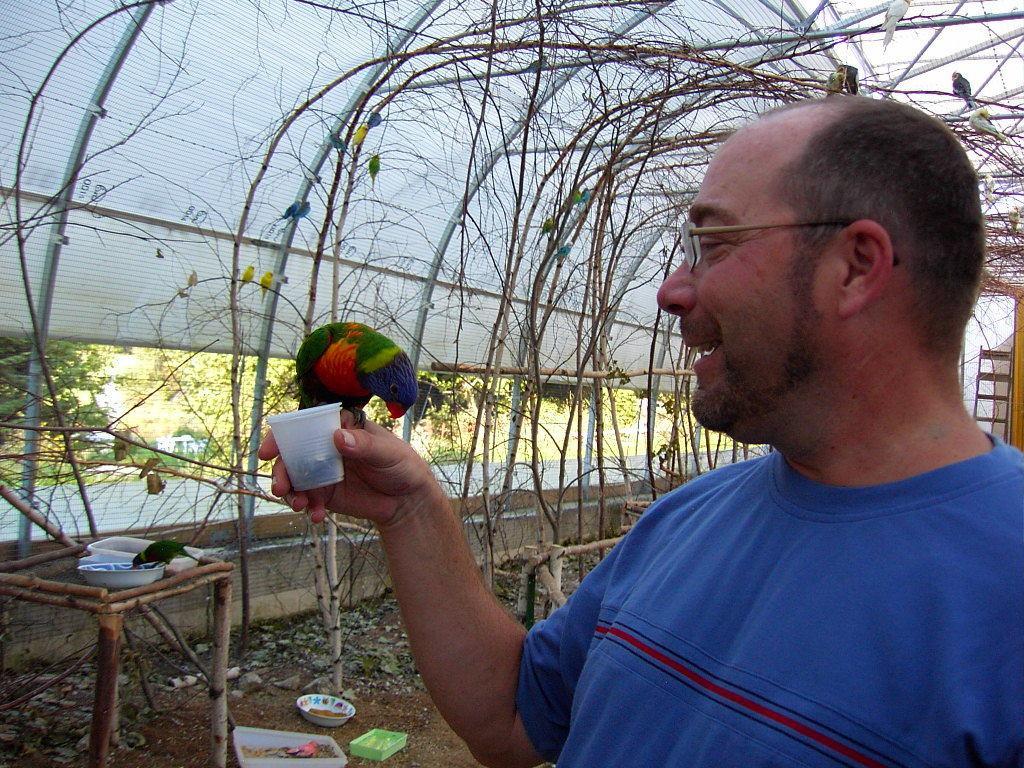In one or two sentences, can you explain what this image depicts? In this image on the right side there is one person who is holding a cup, and one bird and in the background there are trees, wall, plastic board, birds, plants and trees. On the left side there is one table, on the table there are some bowls and baskets. On the basket there is one bird, at the bottom there is sand and some small stones and on the sand there are some bowls and baskets. 